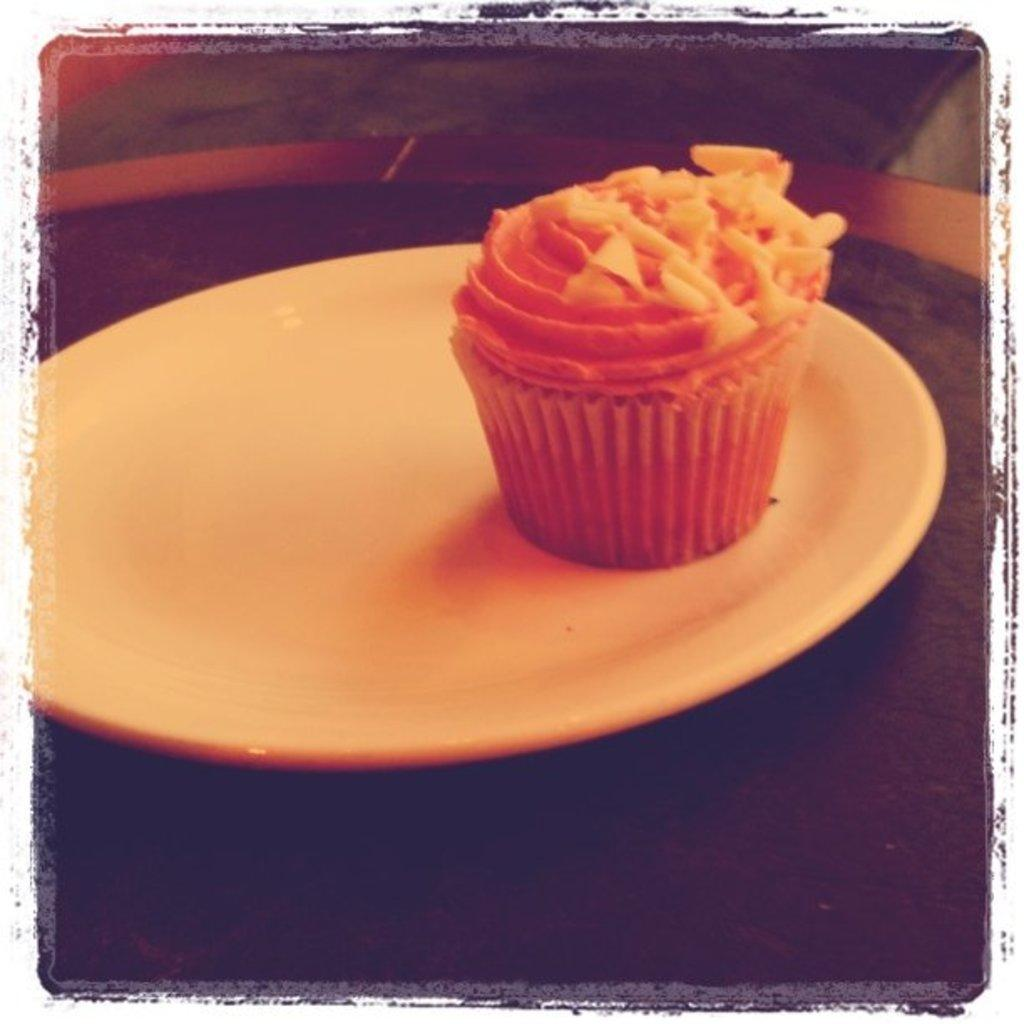What type of food is visible in the image? There is a muffin in the image. Where is the muffin placed? The muffin is on a plate. What color is the plate? The plate is white. How much debt is represented by the muffin in the image? The image does not depict any debt; it features a muffin on a white plate. What country is the muffin from in the image? The image does not provide information about the country of origin for the muffin. 